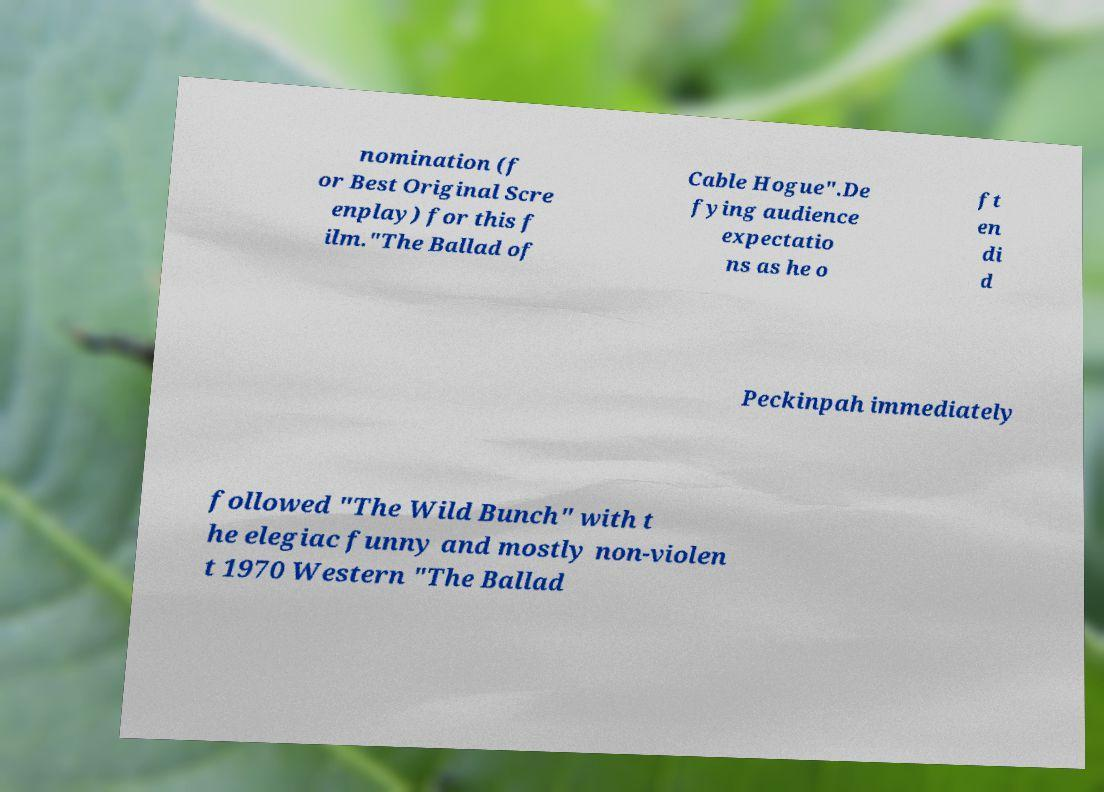Please read and relay the text visible in this image. What does it say? nomination (f or Best Original Scre enplay) for this f ilm."The Ballad of Cable Hogue".De fying audience expectatio ns as he o ft en di d Peckinpah immediately followed "The Wild Bunch" with t he elegiac funny and mostly non-violen t 1970 Western "The Ballad 